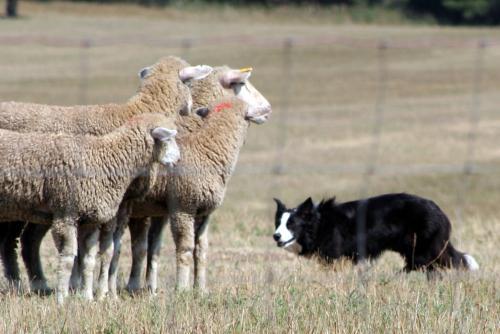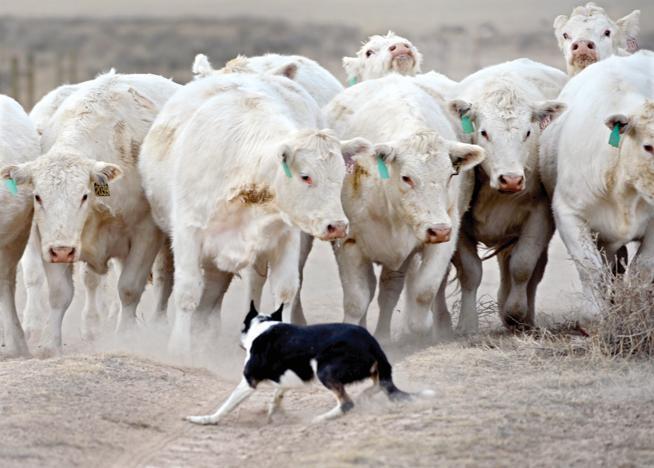The first image is the image on the left, the second image is the image on the right. Considering the images on both sides, is "Dogs herd livestock within a fence line." valid? Answer yes or no. Yes. The first image is the image on the left, the second image is the image on the right. Assess this claim about the two images: "The dog in the left image is facing towards the left.". Correct or not? Answer yes or no. Yes. 